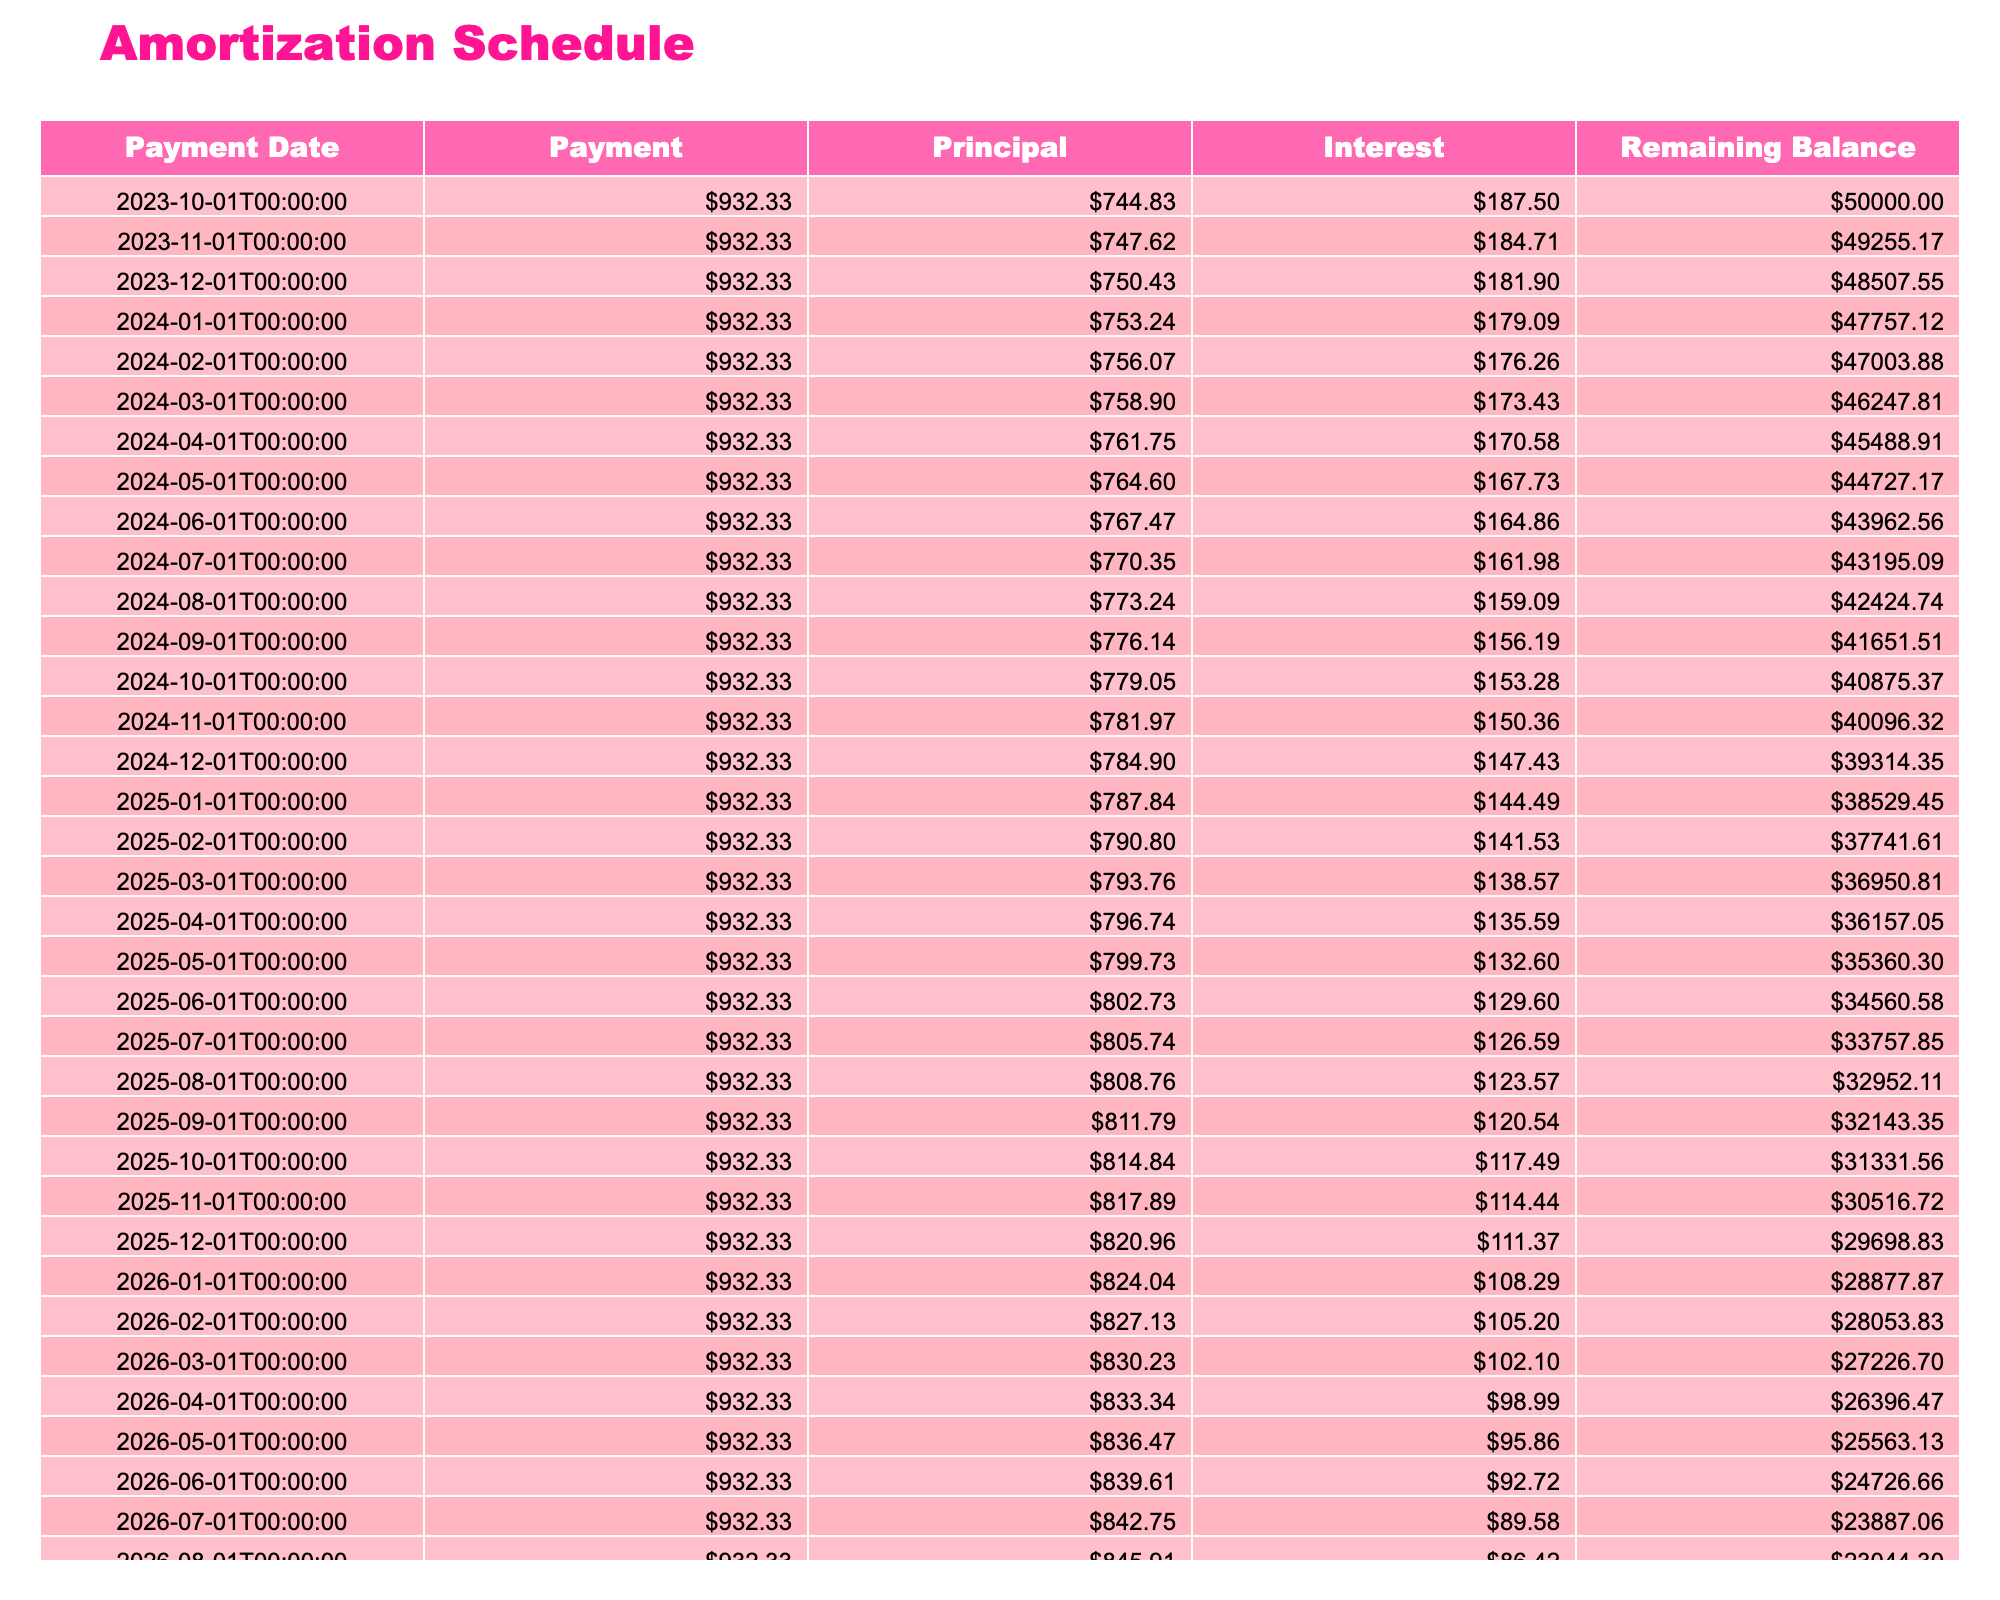What is the loan amount for the women's college basketball program? The table lists the loan amount in the 'Loan Amount' column, which shows 50000.
Answer: 50000 What is the monthly payment for the loan? The 'Monthly Payment' column in the table provides this information, presenting a monthly payment of 932.33.
Answer: 932.33 How much interest is paid in the first month? In the first row under the 'Interest' column, the interest paid is calculated as the remaining balance multiplied by the monthly interest rate, which amounts to 187.50 based on the loan amount and interest rate.
Answer: 187.50 What is the remaining balance after the first payment? The 'Remaining Balance' column shows the value for the first payment period being 49112.50, which is calculated by subtracting the principal paid from the loan amount.
Answer: 49112.50 What is the total interest paid over the loan term? To find the total interest, sum up all the values from the 'Interest' column. There are 60 payments (5 years), and if you sum the monthly interest amounts, the total interest paid will be 2209.94.
Answer: 2209.94 Is the monthly payment the same for every month of the loan? The table indicates that the 'Payment' column displays the same value for each row, confirming that the monthly payment remains consistent throughout the loan period.
Answer: Yes What is the difference in remaining balance after the first and second payments? Subtract the remaining balance after the first payment (49112.50) from the remaining balance after the second payment (48109.69) to determine the difference, which is 1002.81.
Answer: 1002.81 What percentage of the first monthly payment goes toward principal repayment? The principal paid in the first month is calculated as 744.83. To find the percentage, divide this principal by the total monthly payment: (744.83 / 932.33) * 100 = 79.91%.
Answer: 79.91% How much total will be paid on the loan after the full term? Multiply the monthly payment (932.33) by the total number of payments (60). Thus, the total paid on the loan will be 55939.80.
Answer: 55939.80 